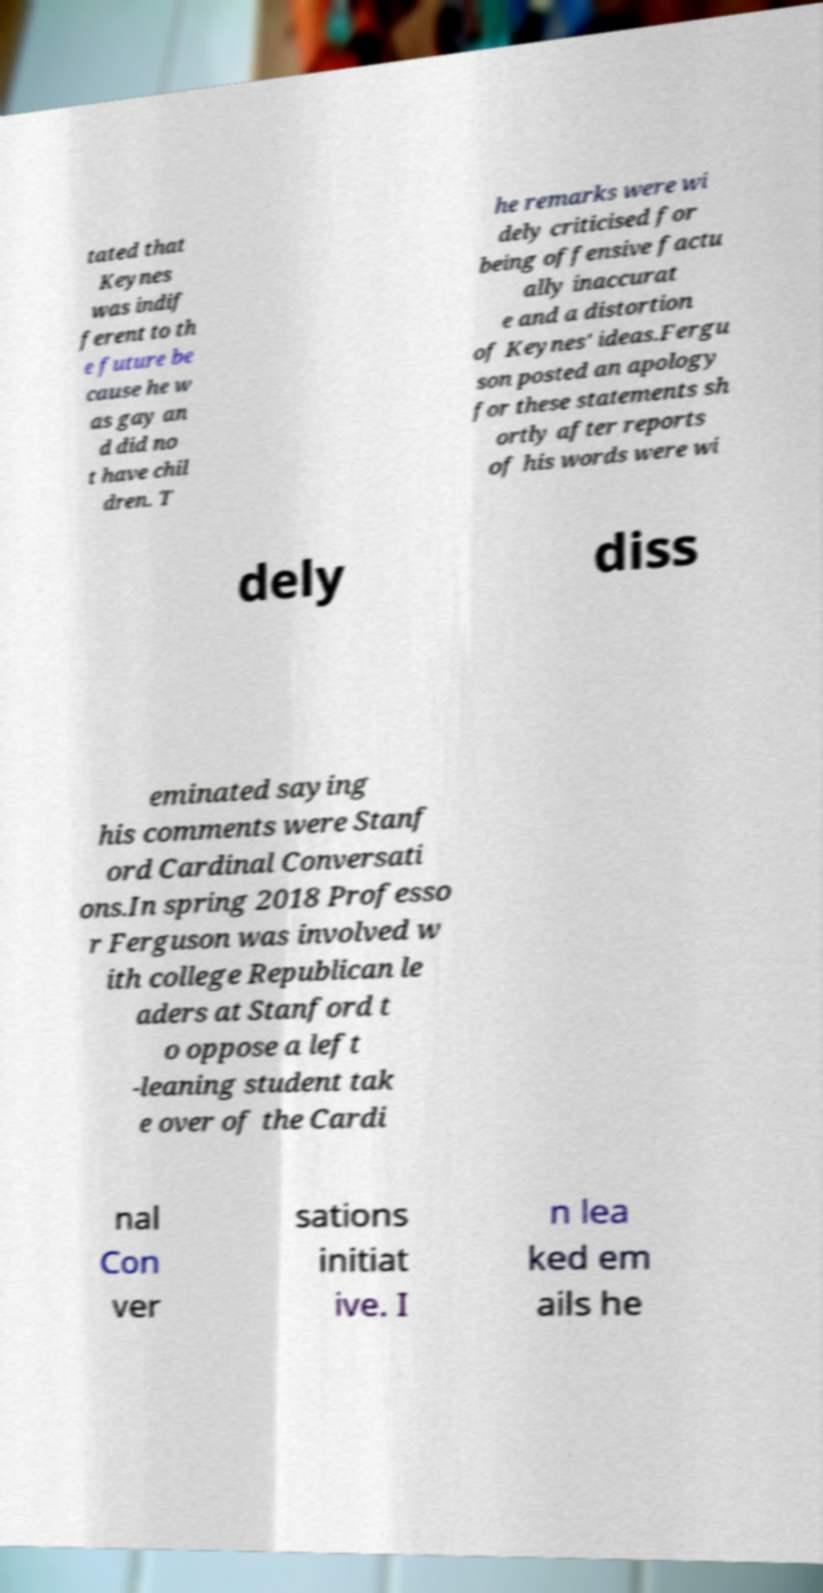Could you extract and type out the text from this image? tated that Keynes was indif ferent to th e future be cause he w as gay an d did no t have chil dren. T he remarks were wi dely criticised for being offensive factu ally inaccurat e and a distortion of Keynes' ideas.Fergu son posted an apology for these statements sh ortly after reports of his words were wi dely diss eminated saying his comments were Stanf ord Cardinal Conversati ons.In spring 2018 Professo r Ferguson was involved w ith college Republican le aders at Stanford t o oppose a left -leaning student tak e over of the Cardi nal Con ver sations initiat ive. I n lea ked em ails he 